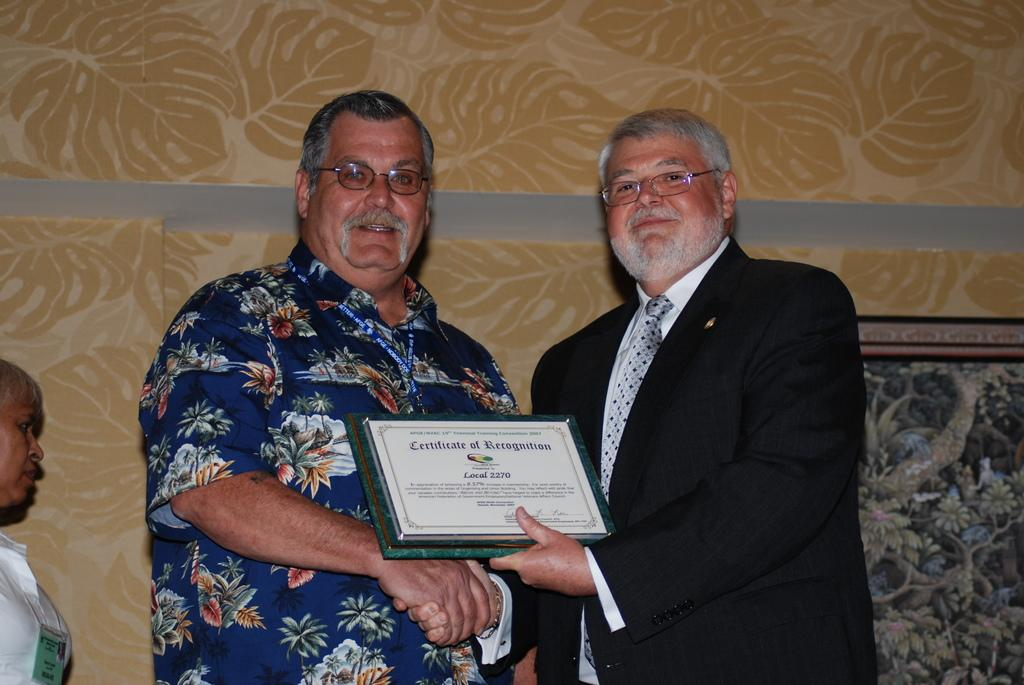How many people are in the image? There are two persons standing in the image. Can you describe the appearance of one of the persons? One person is wearing a coat and spectacles. What is the person with the coat and spectacles holding? The person with the coat and spectacles is holding a certificate. What can be seen in the background of the image? There is a woman in the background of the image. What is the woman in the background wearing? The woman in the background is wearing a white shirt. What type of dolls can be seen in the image? There are no dolls present in the image. Is the person with the coat and spectacles driving a vehicle in the image? There is no vehicle or driving activity depicted in the image. 